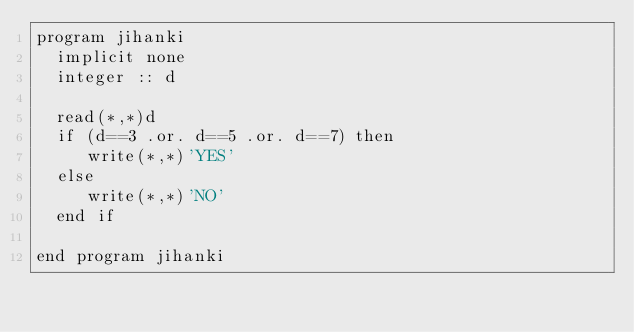Convert code to text. <code><loc_0><loc_0><loc_500><loc_500><_FORTRAN_>program jihanki
  implicit none
  integer :: d

  read(*,*)d
  if (d==3 .or. d==5 .or. d==7) then
     write(*,*)'YES'
  else
     write(*,*)'NO'
  end if
  
end program jihanki
</code> 